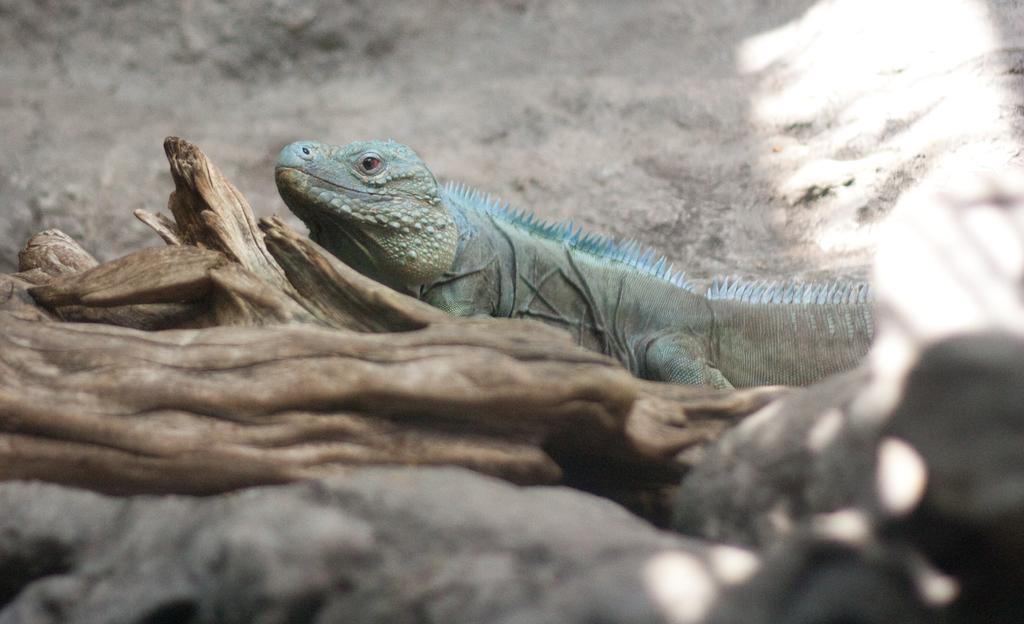Describe this image in one or two sentences. There is a blue color animal near the wooden sticks. 